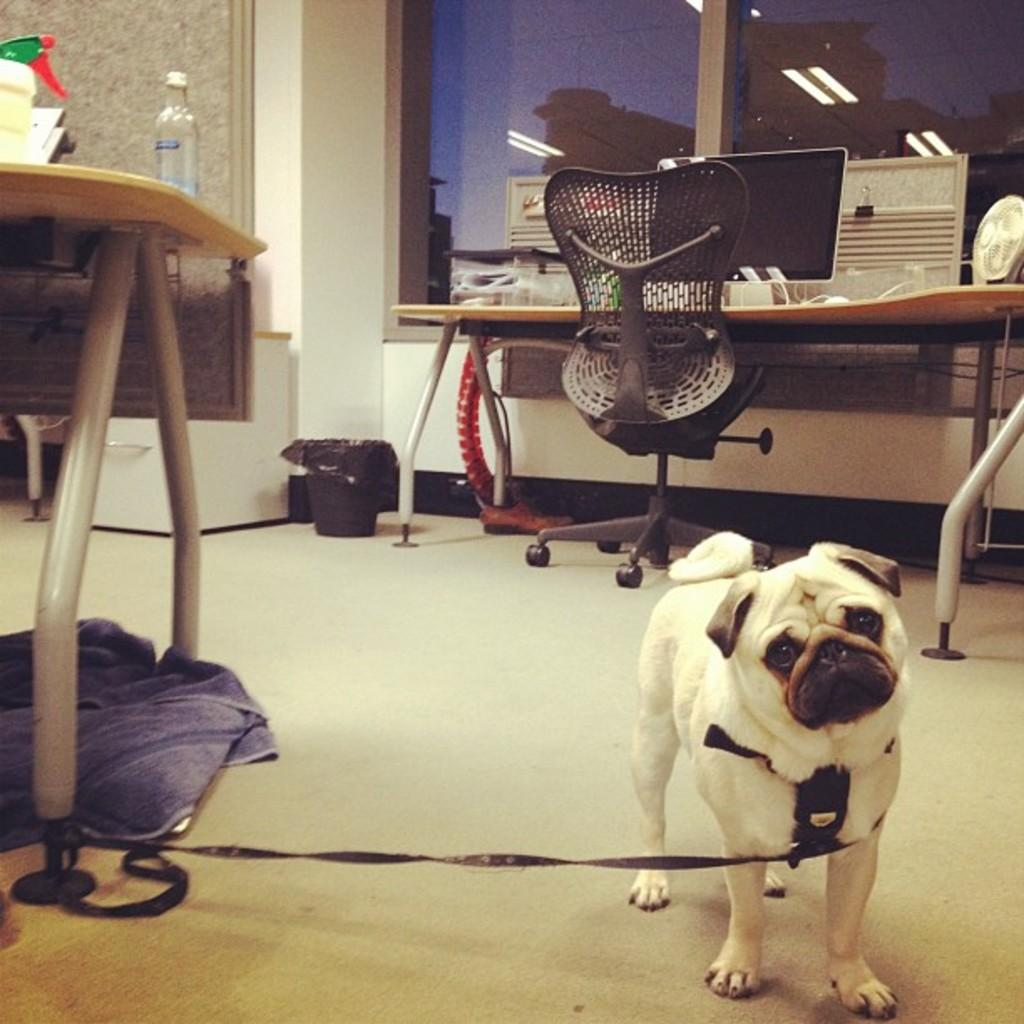How many tables are in the room? There are two tables in the room. How many chairs are in the room? There is one chair in the room. What type of animal is in the room? There is a dog in the room. What electronic device is present on one of the tables? A laptop is present on one of the tables. How many children are playing with the laptop in the room? There are no children present in the image, and the laptop is not being used for play. What type of operation is being performed on the dog in the room? There is no operation being performed on the dog in the room; it is simply present in the image. 